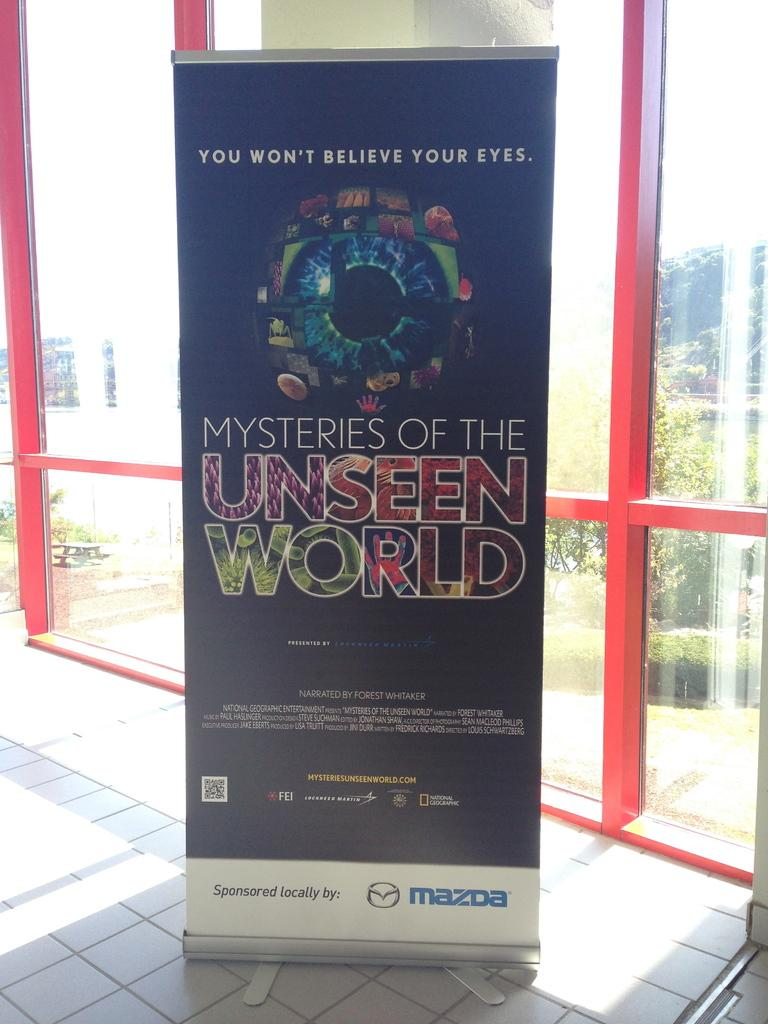<image>
Describe the image concisely. An advertisement for a documentary named "Mysteries of the Unseen World" was sponsored by Mazda. 